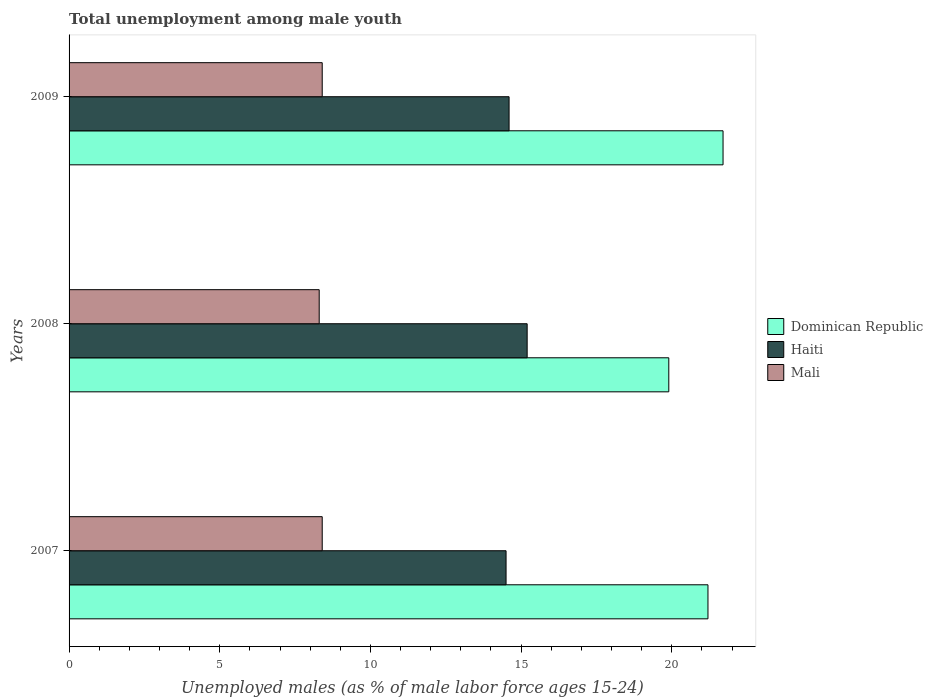How many groups of bars are there?
Make the answer very short. 3. Are the number of bars per tick equal to the number of legend labels?
Provide a short and direct response. Yes. How many bars are there on the 1st tick from the top?
Your answer should be compact. 3. How many bars are there on the 3rd tick from the bottom?
Your response must be concise. 3. What is the percentage of unemployed males in in Haiti in 2009?
Ensure brevity in your answer.  14.6. Across all years, what is the maximum percentage of unemployed males in in Dominican Republic?
Provide a succinct answer. 21.7. In which year was the percentage of unemployed males in in Haiti maximum?
Provide a succinct answer. 2008. What is the total percentage of unemployed males in in Dominican Republic in the graph?
Provide a succinct answer. 62.8. What is the difference between the percentage of unemployed males in in Dominican Republic in 2007 and that in 2008?
Make the answer very short. 1.3. What is the difference between the percentage of unemployed males in in Haiti in 2008 and the percentage of unemployed males in in Dominican Republic in 2007?
Provide a succinct answer. -6. What is the average percentage of unemployed males in in Mali per year?
Provide a short and direct response. 8.37. In the year 2008, what is the difference between the percentage of unemployed males in in Haiti and percentage of unemployed males in in Mali?
Provide a short and direct response. 6.9. In how many years, is the percentage of unemployed males in in Haiti greater than 2 %?
Keep it short and to the point. 3. What is the ratio of the percentage of unemployed males in in Haiti in 2007 to that in 2009?
Provide a succinct answer. 0.99. What is the difference between the highest and the lowest percentage of unemployed males in in Mali?
Offer a terse response. 0.1. In how many years, is the percentage of unemployed males in in Dominican Republic greater than the average percentage of unemployed males in in Dominican Republic taken over all years?
Provide a succinct answer. 2. Is the sum of the percentage of unemployed males in in Dominican Republic in 2007 and 2009 greater than the maximum percentage of unemployed males in in Haiti across all years?
Your answer should be very brief. Yes. What does the 1st bar from the top in 2009 represents?
Offer a very short reply. Mali. What does the 2nd bar from the bottom in 2008 represents?
Offer a very short reply. Haiti. How many bars are there?
Your answer should be compact. 9. Are all the bars in the graph horizontal?
Make the answer very short. Yes. What is the difference between two consecutive major ticks on the X-axis?
Your response must be concise. 5. Does the graph contain any zero values?
Keep it short and to the point. No. Does the graph contain grids?
Offer a terse response. No. Where does the legend appear in the graph?
Keep it short and to the point. Center right. How are the legend labels stacked?
Offer a very short reply. Vertical. What is the title of the graph?
Offer a terse response. Total unemployment among male youth. What is the label or title of the X-axis?
Provide a succinct answer. Unemployed males (as % of male labor force ages 15-24). What is the Unemployed males (as % of male labor force ages 15-24) in Dominican Republic in 2007?
Your response must be concise. 21.2. What is the Unemployed males (as % of male labor force ages 15-24) in Haiti in 2007?
Your response must be concise. 14.5. What is the Unemployed males (as % of male labor force ages 15-24) in Mali in 2007?
Offer a terse response. 8.4. What is the Unemployed males (as % of male labor force ages 15-24) in Dominican Republic in 2008?
Provide a short and direct response. 19.9. What is the Unemployed males (as % of male labor force ages 15-24) of Haiti in 2008?
Ensure brevity in your answer.  15.2. What is the Unemployed males (as % of male labor force ages 15-24) of Mali in 2008?
Give a very brief answer. 8.3. What is the Unemployed males (as % of male labor force ages 15-24) in Dominican Republic in 2009?
Keep it short and to the point. 21.7. What is the Unemployed males (as % of male labor force ages 15-24) in Haiti in 2009?
Your response must be concise. 14.6. What is the Unemployed males (as % of male labor force ages 15-24) in Mali in 2009?
Give a very brief answer. 8.4. Across all years, what is the maximum Unemployed males (as % of male labor force ages 15-24) in Dominican Republic?
Your answer should be very brief. 21.7. Across all years, what is the maximum Unemployed males (as % of male labor force ages 15-24) in Haiti?
Offer a terse response. 15.2. Across all years, what is the maximum Unemployed males (as % of male labor force ages 15-24) in Mali?
Make the answer very short. 8.4. Across all years, what is the minimum Unemployed males (as % of male labor force ages 15-24) in Dominican Republic?
Ensure brevity in your answer.  19.9. Across all years, what is the minimum Unemployed males (as % of male labor force ages 15-24) of Mali?
Your response must be concise. 8.3. What is the total Unemployed males (as % of male labor force ages 15-24) in Dominican Republic in the graph?
Offer a very short reply. 62.8. What is the total Unemployed males (as % of male labor force ages 15-24) of Haiti in the graph?
Give a very brief answer. 44.3. What is the total Unemployed males (as % of male labor force ages 15-24) in Mali in the graph?
Ensure brevity in your answer.  25.1. What is the difference between the Unemployed males (as % of male labor force ages 15-24) in Dominican Republic in 2007 and that in 2008?
Keep it short and to the point. 1.3. What is the difference between the Unemployed males (as % of male labor force ages 15-24) in Haiti in 2007 and that in 2008?
Your answer should be very brief. -0.7. What is the difference between the Unemployed males (as % of male labor force ages 15-24) in Mali in 2007 and that in 2008?
Offer a terse response. 0.1. What is the difference between the Unemployed males (as % of male labor force ages 15-24) in Mali in 2007 and that in 2009?
Your answer should be very brief. 0. What is the difference between the Unemployed males (as % of male labor force ages 15-24) in Dominican Republic in 2007 and the Unemployed males (as % of male labor force ages 15-24) in Haiti in 2008?
Offer a very short reply. 6. What is the difference between the Unemployed males (as % of male labor force ages 15-24) in Dominican Republic in 2007 and the Unemployed males (as % of male labor force ages 15-24) in Mali in 2008?
Your answer should be very brief. 12.9. What is the average Unemployed males (as % of male labor force ages 15-24) of Dominican Republic per year?
Offer a terse response. 20.93. What is the average Unemployed males (as % of male labor force ages 15-24) of Haiti per year?
Make the answer very short. 14.77. What is the average Unemployed males (as % of male labor force ages 15-24) of Mali per year?
Keep it short and to the point. 8.37. In the year 2007, what is the difference between the Unemployed males (as % of male labor force ages 15-24) of Dominican Republic and Unemployed males (as % of male labor force ages 15-24) of Mali?
Your response must be concise. 12.8. In the year 2007, what is the difference between the Unemployed males (as % of male labor force ages 15-24) of Haiti and Unemployed males (as % of male labor force ages 15-24) of Mali?
Ensure brevity in your answer.  6.1. In the year 2009, what is the difference between the Unemployed males (as % of male labor force ages 15-24) of Dominican Republic and Unemployed males (as % of male labor force ages 15-24) of Mali?
Make the answer very short. 13.3. What is the ratio of the Unemployed males (as % of male labor force ages 15-24) of Dominican Republic in 2007 to that in 2008?
Offer a terse response. 1.07. What is the ratio of the Unemployed males (as % of male labor force ages 15-24) of Haiti in 2007 to that in 2008?
Offer a terse response. 0.95. What is the ratio of the Unemployed males (as % of male labor force ages 15-24) of Mali in 2007 to that in 2008?
Your answer should be very brief. 1.01. What is the ratio of the Unemployed males (as % of male labor force ages 15-24) in Haiti in 2007 to that in 2009?
Ensure brevity in your answer.  0.99. What is the ratio of the Unemployed males (as % of male labor force ages 15-24) of Mali in 2007 to that in 2009?
Offer a very short reply. 1. What is the ratio of the Unemployed males (as % of male labor force ages 15-24) in Dominican Republic in 2008 to that in 2009?
Ensure brevity in your answer.  0.92. What is the ratio of the Unemployed males (as % of male labor force ages 15-24) of Haiti in 2008 to that in 2009?
Keep it short and to the point. 1.04. What is the difference between the highest and the second highest Unemployed males (as % of male labor force ages 15-24) of Haiti?
Offer a terse response. 0.6. What is the difference between the highest and the second highest Unemployed males (as % of male labor force ages 15-24) of Mali?
Provide a succinct answer. 0. What is the difference between the highest and the lowest Unemployed males (as % of male labor force ages 15-24) in Haiti?
Keep it short and to the point. 0.7. 